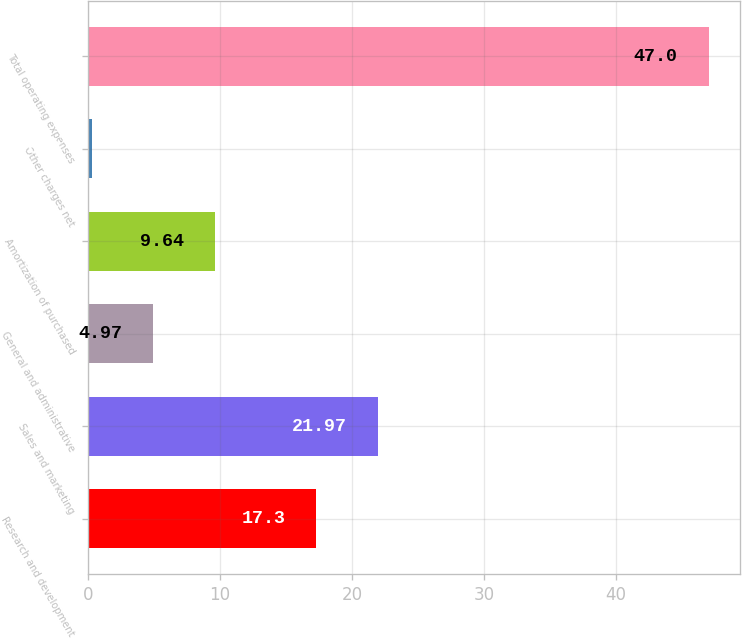Convert chart. <chart><loc_0><loc_0><loc_500><loc_500><bar_chart><fcel>Research and development<fcel>Sales and marketing<fcel>General and administrative<fcel>Amortization of purchased<fcel>Other charges net<fcel>Total operating expenses<nl><fcel>17.3<fcel>21.97<fcel>4.97<fcel>9.64<fcel>0.3<fcel>47<nl></chart> 